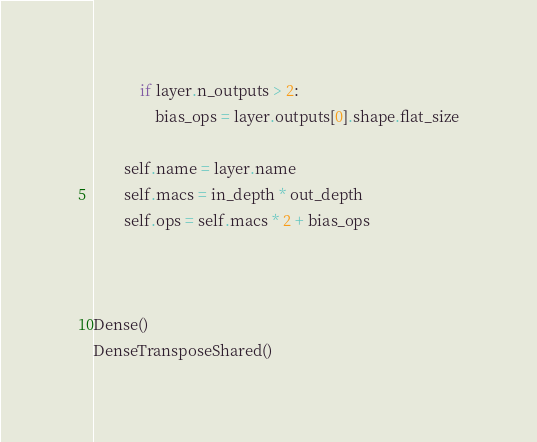Convert code to text. <code><loc_0><loc_0><loc_500><loc_500><_Python_>            if layer.n_outputs > 2:
                bias_ops = layer.outputs[0].shape.flat_size
        
        self.name = layer.name
        self.macs = in_depth * out_depth
        self.ops = self.macs * 2 + bias_ops
        
        

Dense()
DenseTransposeShared()
</code> 